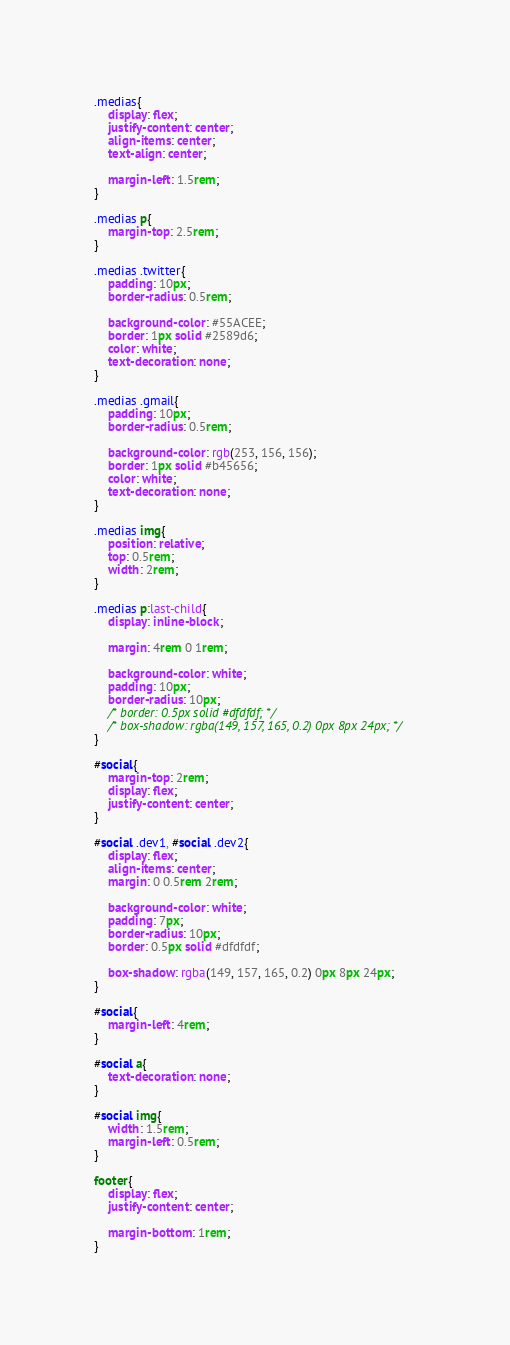<code> <loc_0><loc_0><loc_500><loc_500><_CSS_>.medias{
    display: flex;
    justify-content: center;
    align-items: center;
    text-align: center;

    margin-left: 1.5rem;
}

.medias p{
    margin-top: 2.5rem;
}

.medias .twitter{
    padding: 10px;
    border-radius: 0.5rem;

    background-color: #55ACEE;
    border: 1px solid #2589d6;
    color: white;
    text-decoration: none;
}

.medias .gmail{
    padding: 10px;
    border-radius: 0.5rem;

    background-color: rgb(253, 156, 156);
    border: 1px solid #b45656;
    color: white;
    text-decoration: none;
}

.medias img{
    position: relative;
    top: 0.5rem;
    width: 2rem;
}

.medias p:last-child{
    display: inline-block;
    
    margin: 4rem 0 1rem;

    background-color: white;
    padding: 10px;
    border-radius: 10px;
    /* border: 0.5px solid #dfdfdf; */
    /* box-shadow: rgba(149, 157, 165, 0.2) 0px 8px 24px; */
}

#social{
    margin-top: 2rem;
    display: flex;
    justify-content: center;
}

#social .dev1, #social .dev2{
    display: flex;
    align-items: center;
    margin: 0 0.5rem 2rem;

    background-color: white;
    padding: 7px;
    border-radius: 10px;
    border: 0.5px solid #dfdfdf;

    box-shadow: rgba(149, 157, 165, 0.2) 0px 8px 24px;
}

#social{
    margin-left: 4rem;
}

#social a{
    text-decoration: none;
}

#social img{
    width: 1.5rem;
    margin-left: 0.5rem;
}

footer{
    display: flex;
    justify-content: center;

    margin-bottom: 1rem;
}
</code> 